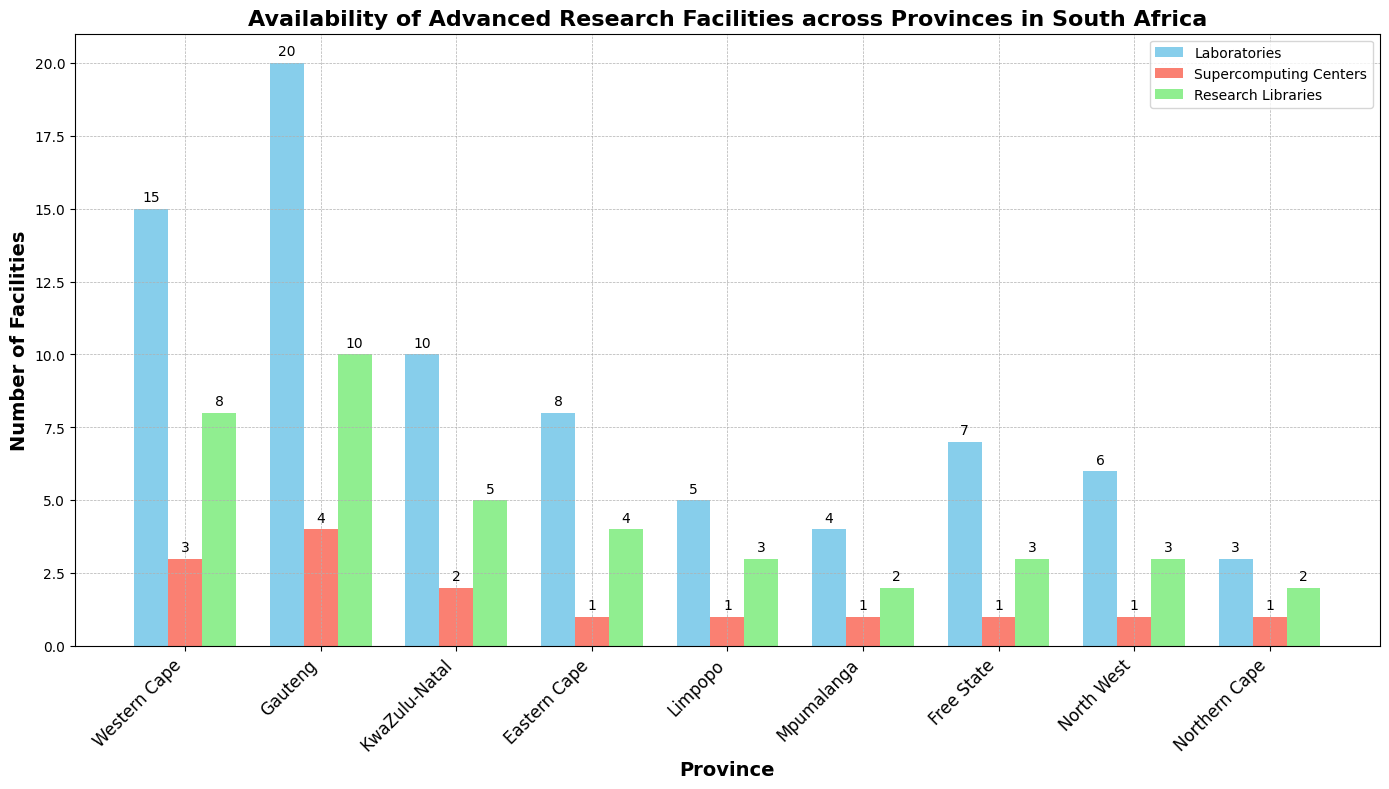Which province has the most laboratories? By looking at the heights of the blue bars representing Laboratories, Gauteng has the tallest bar indicating the highest count.
Answer: Gauteng How many total facilities (all types) are there in the Western Cape? Sum the numbers of Laboratories, Supercomputing Centers, and Research Libraries for Western Cape (15 + 3 + 8).
Answer: 26 Which facility type is most common in KwaZulu-Natal? Compare the heights of the three bars for KwaZulu-Natal; the blue bar (Laboratories) is the tallest.
Answer: Laboratories Is there a province with an equal number of Research Libraries and Laboratories? Look for provinces where the green and blue bars have the same height; no province meets this criterion.
Answer: No What is the average number of Supercomputing Centers per province? Sum the counts of Supercomputing Centers for all provinces (3 + 4 + 2 + 1 + 1 + 1 + 1 + 1) and divide by the number of provinces (9).
Answer: 1.78 Which province has the highest number of Research Libraries? Identify the province with the tallest green bar representing Research Libraries, which is Gauteng.
Answer: Gauteng Compare the number of Laboratories in Western Cape and KwaZulu-Natal. Which one has more? Compare the heights of the blue bars for Western Cape (15) and KwaZulu-Natal (10); Western Cape has more.
Answer: Western Cape How many fewer Supercomputing Centers are there in the Eastern Cape compared to Gauteng? Subtract the number of Supercomputing Centers in Eastern Cape (1) from that in Gauteng (4).
Answer: 3 What is the total number of Supercomputing Centers in provinces with fewer than 10 Laboratories? Identify provinces with fewer than 10 Laboratories (Eastern Cape, Limpopo, Mpumalanga, Free State, North West, Northern Cape) and sum their Supercomputing Centers (1 + 1 + 1 + 1 + 1 + 1).
Answer: 6 Which province has the least variety in types of facilities? Identify the province where the bars are closest in height. Both Northern Cape and Mpumalanga have equal numbers of Laboratories, Supercomputing Centers, and Research Libraries.
Answer: Northern Cape, Mpumalanga 